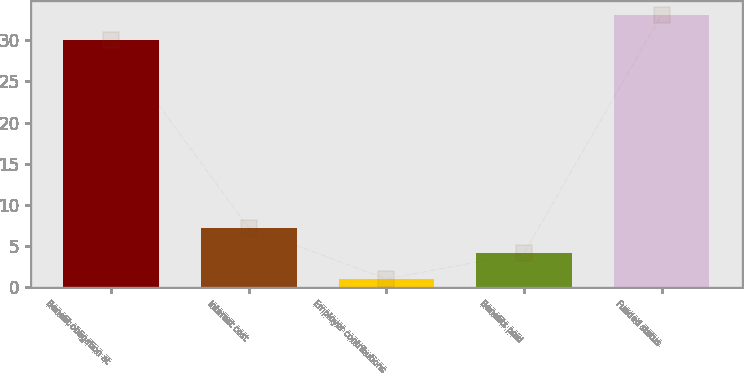Convert chart. <chart><loc_0><loc_0><loc_500><loc_500><bar_chart><fcel>Benefit obligation at<fcel>Interest cost<fcel>Employer contributions<fcel>Benefits paid<fcel>Funded status<nl><fcel>30<fcel>7.2<fcel>1<fcel>4.1<fcel>33.1<nl></chart> 